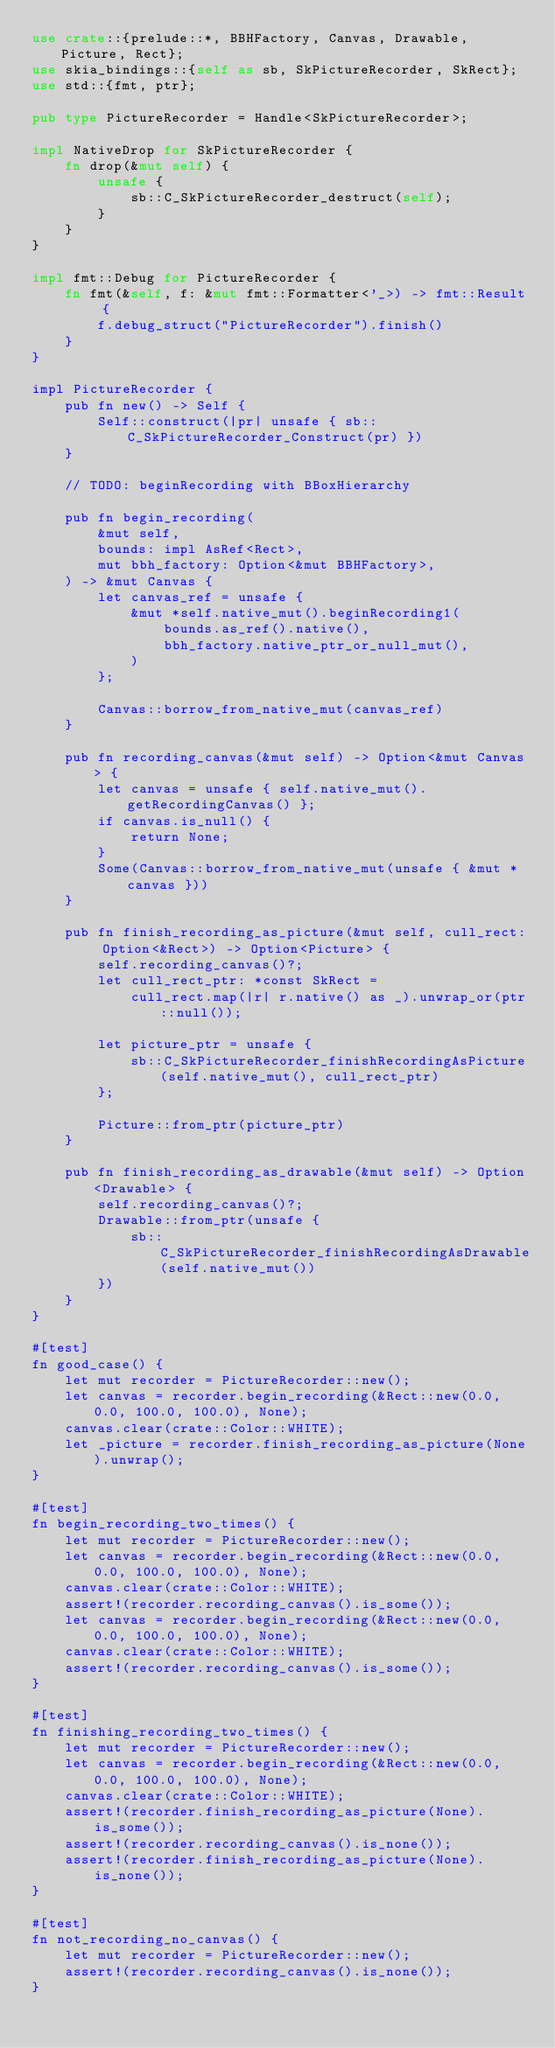Convert code to text. <code><loc_0><loc_0><loc_500><loc_500><_Rust_>use crate::{prelude::*, BBHFactory, Canvas, Drawable, Picture, Rect};
use skia_bindings::{self as sb, SkPictureRecorder, SkRect};
use std::{fmt, ptr};

pub type PictureRecorder = Handle<SkPictureRecorder>;

impl NativeDrop for SkPictureRecorder {
    fn drop(&mut self) {
        unsafe {
            sb::C_SkPictureRecorder_destruct(self);
        }
    }
}

impl fmt::Debug for PictureRecorder {
    fn fmt(&self, f: &mut fmt::Formatter<'_>) -> fmt::Result {
        f.debug_struct("PictureRecorder").finish()
    }
}

impl PictureRecorder {
    pub fn new() -> Self {
        Self::construct(|pr| unsafe { sb::C_SkPictureRecorder_Construct(pr) })
    }

    // TODO: beginRecording with BBoxHierarchy

    pub fn begin_recording(
        &mut self,
        bounds: impl AsRef<Rect>,
        mut bbh_factory: Option<&mut BBHFactory>,
    ) -> &mut Canvas {
        let canvas_ref = unsafe {
            &mut *self.native_mut().beginRecording1(
                bounds.as_ref().native(),
                bbh_factory.native_ptr_or_null_mut(),
            )
        };

        Canvas::borrow_from_native_mut(canvas_ref)
    }

    pub fn recording_canvas(&mut self) -> Option<&mut Canvas> {
        let canvas = unsafe { self.native_mut().getRecordingCanvas() };
        if canvas.is_null() {
            return None;
        }
        Some(Canvas::borrow_from_native_mut(unsafe { &mut *canvas }))
    }

    pub fn finish_recording_as_picture(&mut self, cull_rect: Option<&Rect>) -> Option<Picture> {
        self.recording_canvas()?;
        let cull_rect_ptr: *const SkRect =
            cull_rect.map(|r| r.native() as _).unwrap_or(ptr::null());

        let picture_ptr = unsafe {
            sb::C_SkPictureRecorder_finishRecordingAsPicture(self.native_mut(), cull_rect_ptr)
        };

        Picture::from_ptr(picture_ptr)
    }

    pub fn finish_recording_as_drawable(&mut self) -> Option<Drawable> {
        self.recording_canvas()?;
        Drawable::from_ptr(unsafe {
            sb::C_SkPictureRecorder_finishRecordingAsDrawable(self.native_mut())
        })
    }
}

#[test]
fn good_case() {
    let mut recorder = PictureRecorder::new();
    let canvas = recorder.begin_recording(&Rect::new(0.0, 0.0, 100.0, 100.0), None);
    canvas.clear(crate::Color::WHITE);
    let _picture = recorder.finish_recording_as_picture(None).unwrap();
}

#[test]
fn begin_recording_two_times() {
    let mut recorder = PictureRecorder::new();
    let canvas = recorder.begin_recording(&Rect::new(0.0, 0.0, 100.0, 100.0), None);
    canvas.clear(crate::Color::WHITE);
    assert!(recorder.recording_canvas().is_some());
    let canvas = recorder.begin_recording(&Rect::new(0.0, 0.0, 100.0, 100.0), None);
    canvas.clear(crate::Color::WHITE);
    assert!(recorder.recording_canvas().is_some());
}

#[test]
fn finishing_recording_two_times() {
    let mut recorder = PictureRecorder::new();
    let canvas = recorder.begin_recording(&Rect::new(0.0, 0.0, 100.0, 100.0), None);
    canvas.clear(crate::Color::WHITE);
    assert!(recorder.finish_recording_as_picture(None).is_some());
    assert!(recorder.recording_canvas().is_none());
    assert!(recorder.finish_recording_as_picture(None).is_none());
}

#[test]
fn not_recording_no_canvas() {
    let mut recorder = PictureRecorder::new();
    assert!(recorder.recording_canvas().is_none());
}
</code> 